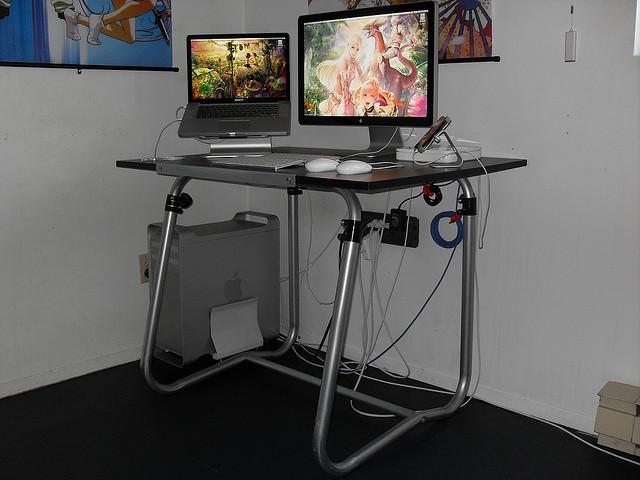What is this room?
Quick response, please. Office. What is the desk made of?
Short answer required. Metal. Is the monitor on?
Short answer required. Yes. Are there a lot of wires?
Keep it brief. Yes. 